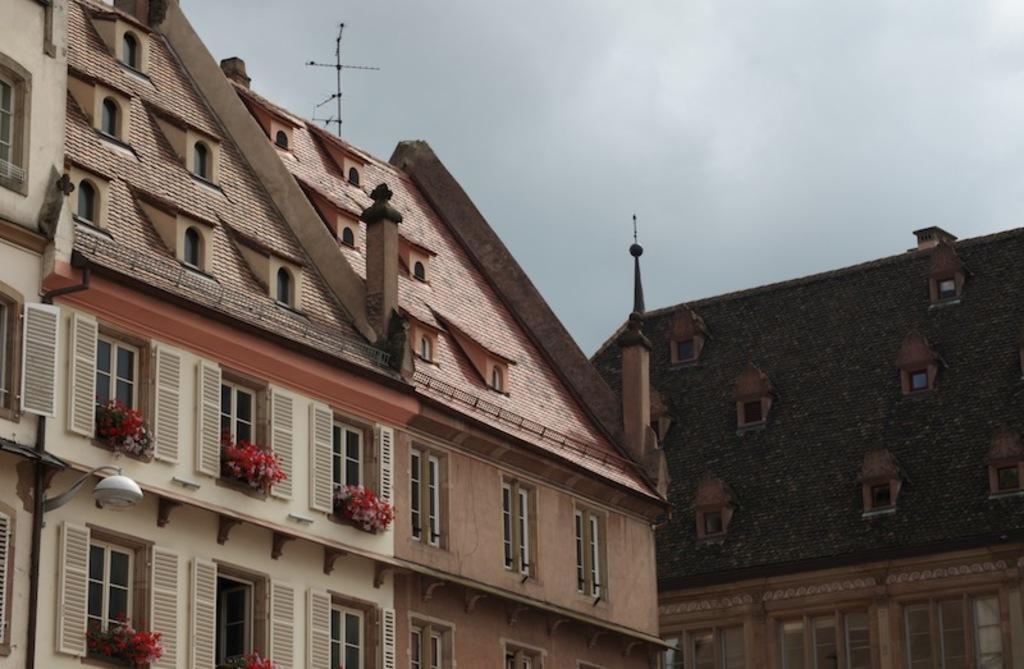Describe this image in one or two sentences. Here in this picture we can see buildings present and we can also see number of windows on it and we can see some flower plants present near the windows and at the top of it we can see an antenna present and we can see the sky is fully covered with clouds and on the left side we can see a lamp post present. 